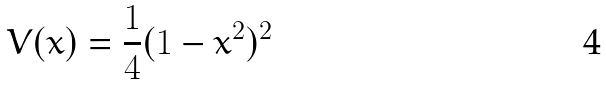<formula> <loc_0><loc_0><loc_500><loc_500>V ( x ) = \frac { 1 } { 4 } ( 1 - x ^ { 2 } ) ^ { 2 }</formula> 